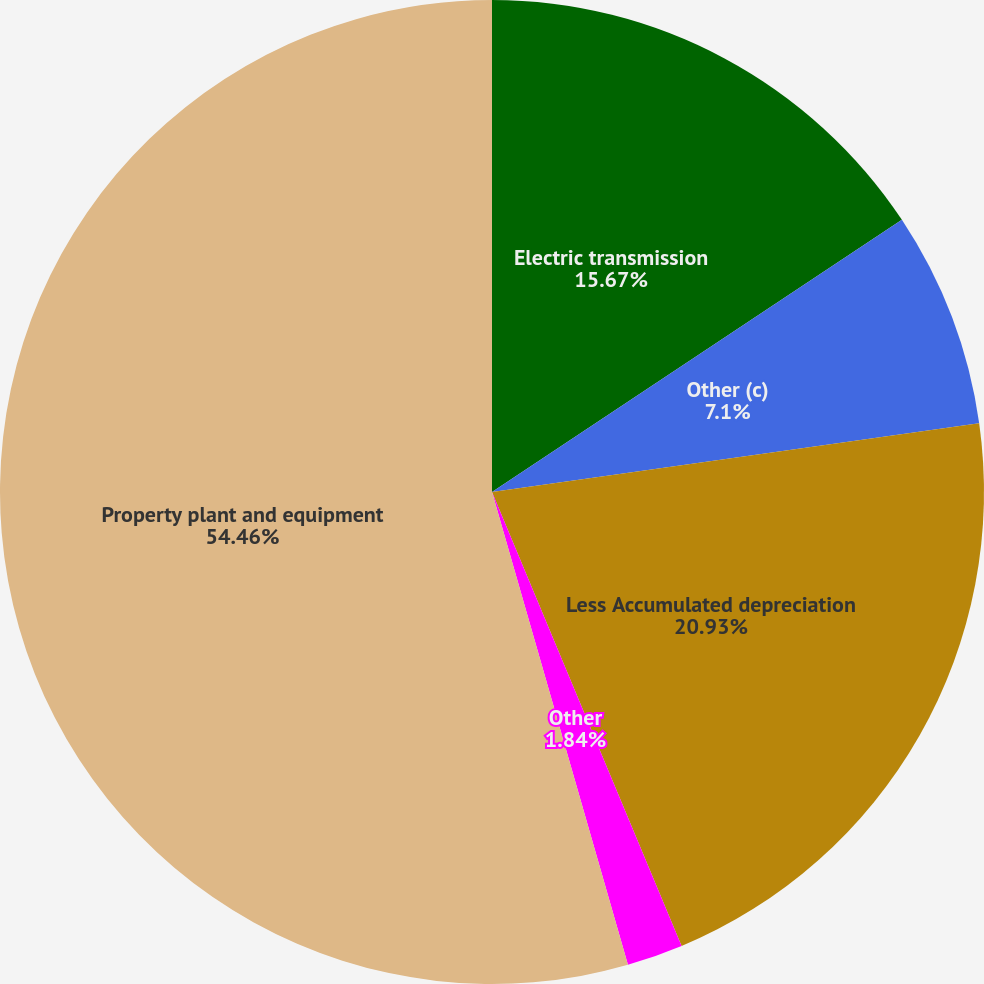Convert chart. <chart><loc_0><loc_0><loc_500><loc_500><pie_chart><fcel>Electric transmission<fcel>Other (c)<fcel>Less Accumulated depreciation<fcel>Other<fcel>Property plant and equipment<nl><fcel>15.67%<fcel>7.1%<fcel>20.93%<fcel>1.84%<fcel>54.45%<nl></chart> 